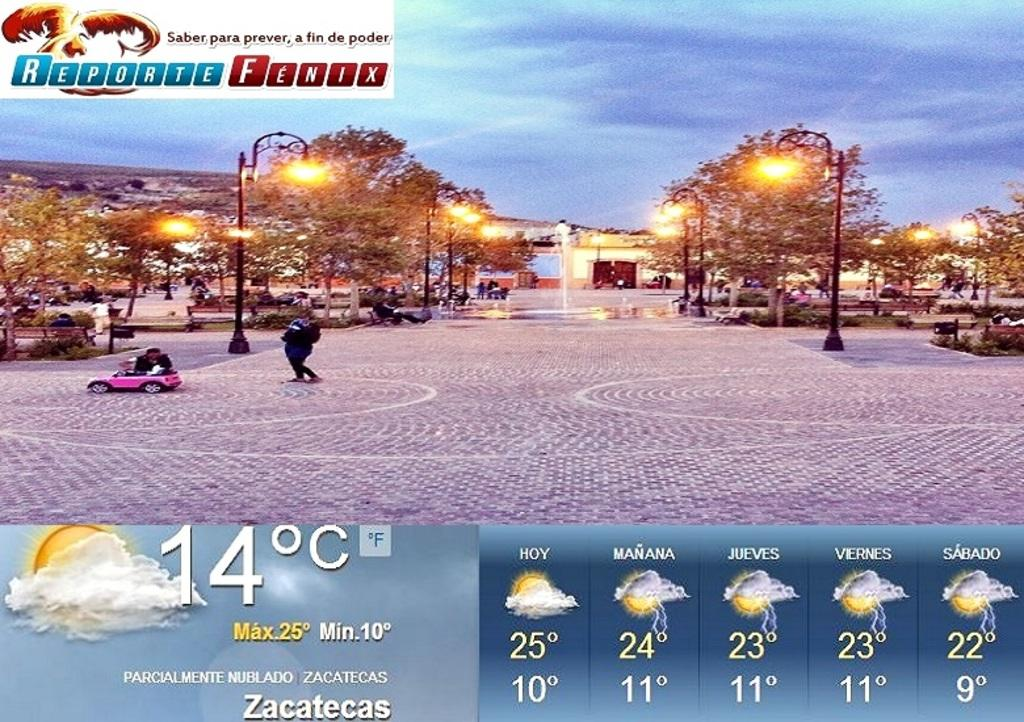<image>
Give a short and clear explanation of the subsequent image. According to the weather report it is 14 degrees C in Zacatecas, but later it will be going up to 25 degrees. 